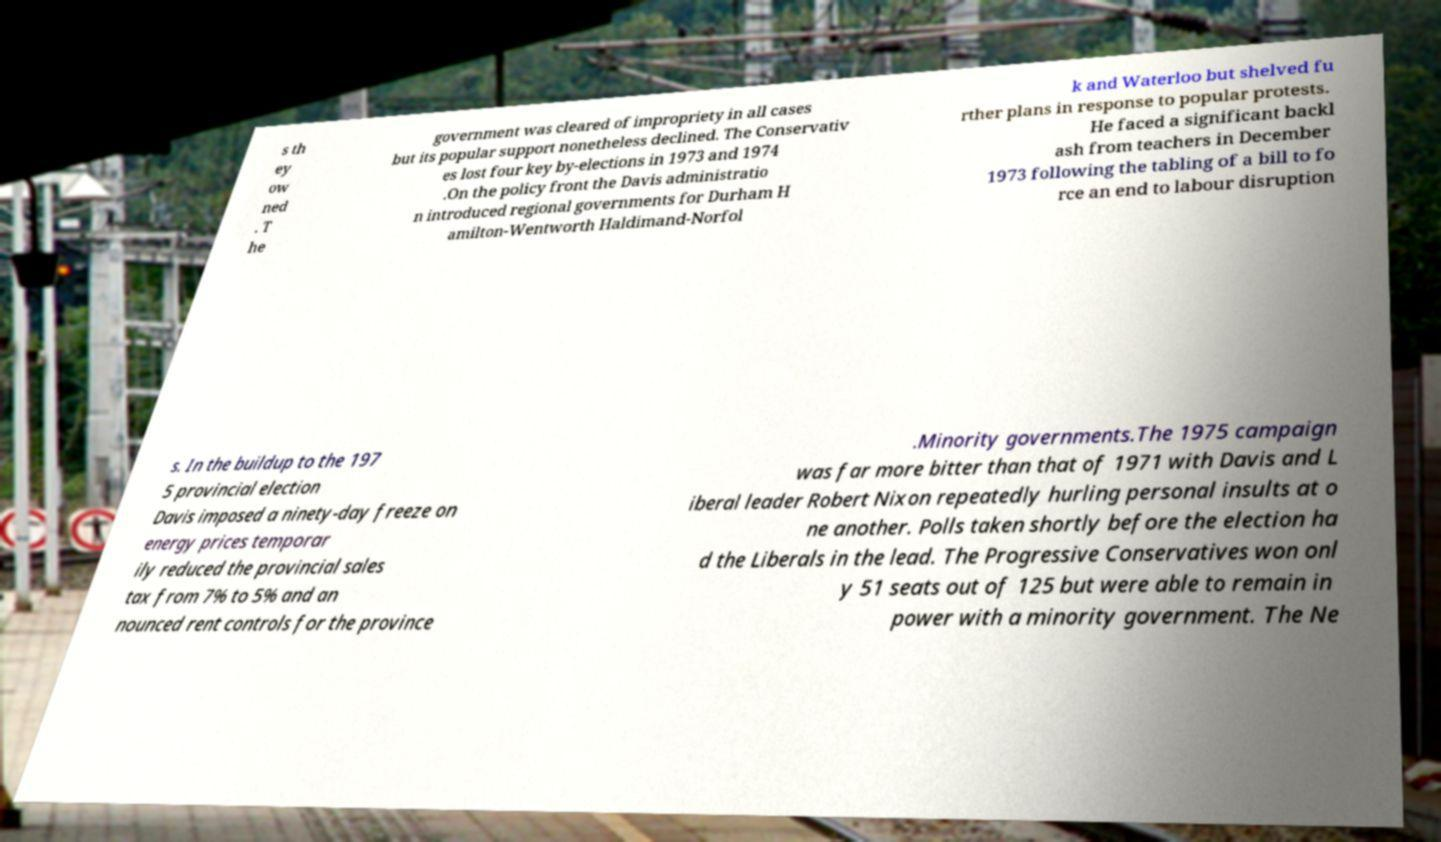There's text embedded in this image that I need extracted. Can you transcribe it verbatim? s th ey ow ned . T he government was cleared of impropriety in all cases but its popular support nonetheless declined. The Conservativ es lost four key by-elections in 1973 and 1974 .On the policy front the Davis administratio n introduced regional governments for Durham H amilton-Wentworth Haldimand-Norfol k and Waterloo but shelved fu rther plans in response to popular protests. He faced a significant backl ash from teachers in December 1973 following the tabling of a bill to fo rce an end to labour disruption s. In the buildup to the 197 5 provincial election Davis imposed a ninety-day freeze on energy prices temporar ily reduced the provincial sales tax from 7% to 5% and an nounced rent controls for the province .Minority governments.The 1975 campaign was far more bitter than that of 1971 with Davis and L iberal leader Robert Nixon repeatedly hurling personal insults at o ne another. Polls taken shortly before the election ha d the Liberals in the lead. The Progressive Conservatives won onl y 51 seats out of 125 but were able to remain in power with a minority government. The Ne 